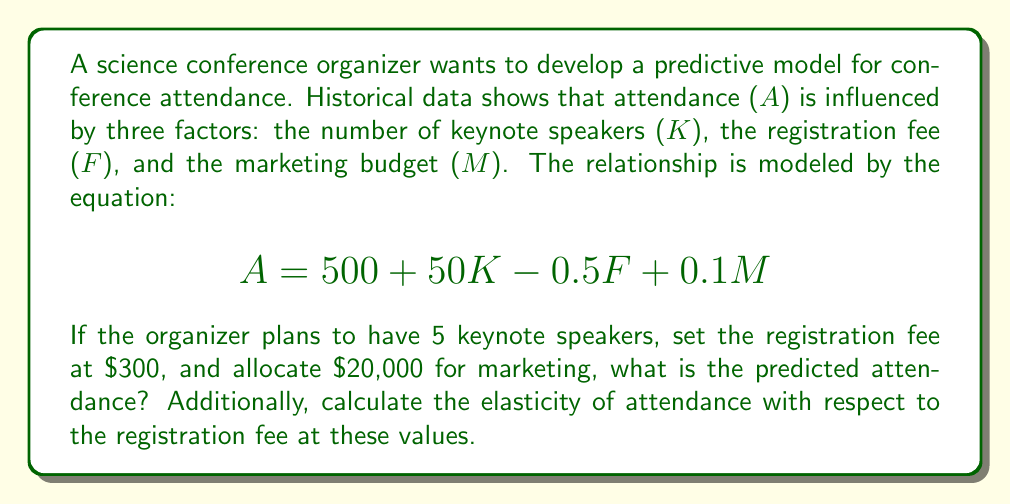Provide a solution to this math problem. To solve this problem, we'll follow these steps:

1. Calculate the predicted attendance:
   Substitute the given values into the equation:
   $$A = 500 + 50K - 0.5F + 0.1M$$
   $$A = 500 + 50(5) - 0.5(300) + 0.1(20000)$$
   $$A = 500 + 250 - 150 + 2000$$
   $$A = 2600$$

2. Calculate the elasticity of attendance with respect to the registration fee:
   The elasticity formula is:
   $$E = \frac{\partial A}{\partial F} \cdot \frac{F}{A}$$

   Where:
   $\frac{\partial A}{\partial F}$ is the partial derivative of $A$ with respect to $F$
   $F$ is the current value of the registration fee
   $A$ is the current predicted attendance

   From the given equation, we can see that $\frac{\partial A}{\partial F} = -0.5$

   Substituting the values:
   $$E = -0.5 \cdot \frac{300}{2600}$$
   $$E = -0.0577$$

The negative sign indicates that as the registration fee increases, attendance decreases, which is expected.
Answer: The predicted attendance is 2,600 people. The elasticity of attendance with respect to the registration fee is -0.0577. 